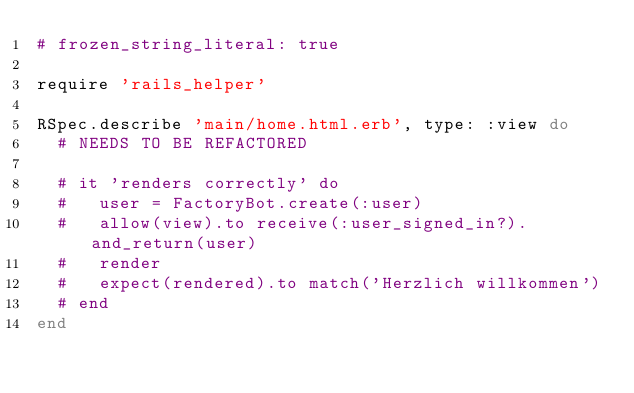Convert code to text. <code><loc_0><loc_0><loc_500><loc_500><_Ruby_># frozen_string_literal: true

require 'rails_helper'

RSpec.describe 'main/home.html.erb', type: :view do
  # NEEDS TO BE REFACTORED

  # it 'renders correctly' do
  #   user = FactoryBot.create(:user)
  #   allow(view).to receive(:user_signed_in?).and_return(user)
  #   render
  #   expect(rendered).to match('Herzlich willkommen')
  # end
end
</code> 